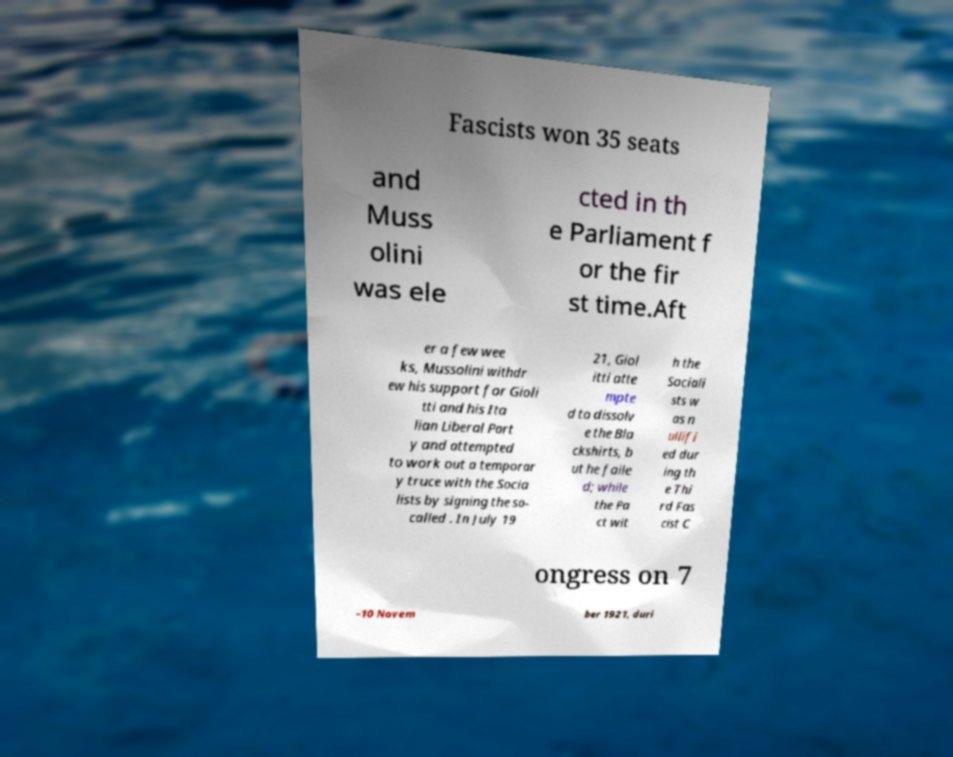Can you read and provide the text displayed in the image?This photo seems to have some interesting text. Can you extract and type it out for me? Fascists won 35 seats and Muss olini was ele cted in th e Parliament f or the fir st time.Aft er a few wee ks, Mussolini withdr ew his support for Gioli tti and his Ita lian Liberal Part y and attempted to work out a temporar y truce with the Socia lists by signing the so- called . In July 19 21, Giol itti atte mpte d to dissolv e the Bla ckshirts, b ut he faile d; while the Pa ct wit h the Sociali sts w as n ullifi ed dur ing th e Thi rd Fas cist C ongress on 7 –10 Novem ber 1921, duri 